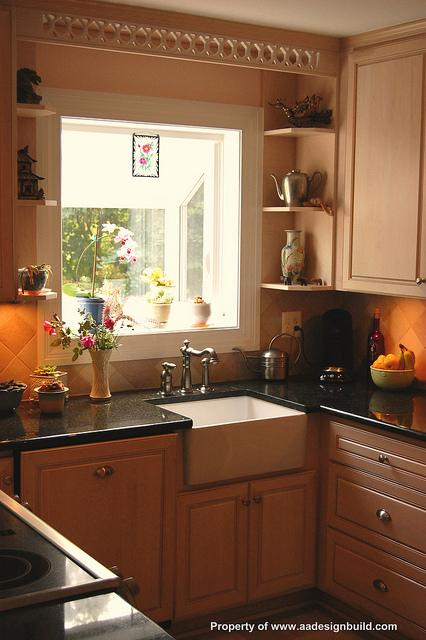What type of animals are shown on the lowest shelf to the right of the sink?

Choices:
A) gorillas
B) dogs
C) giraffes
D) elephants elephants 